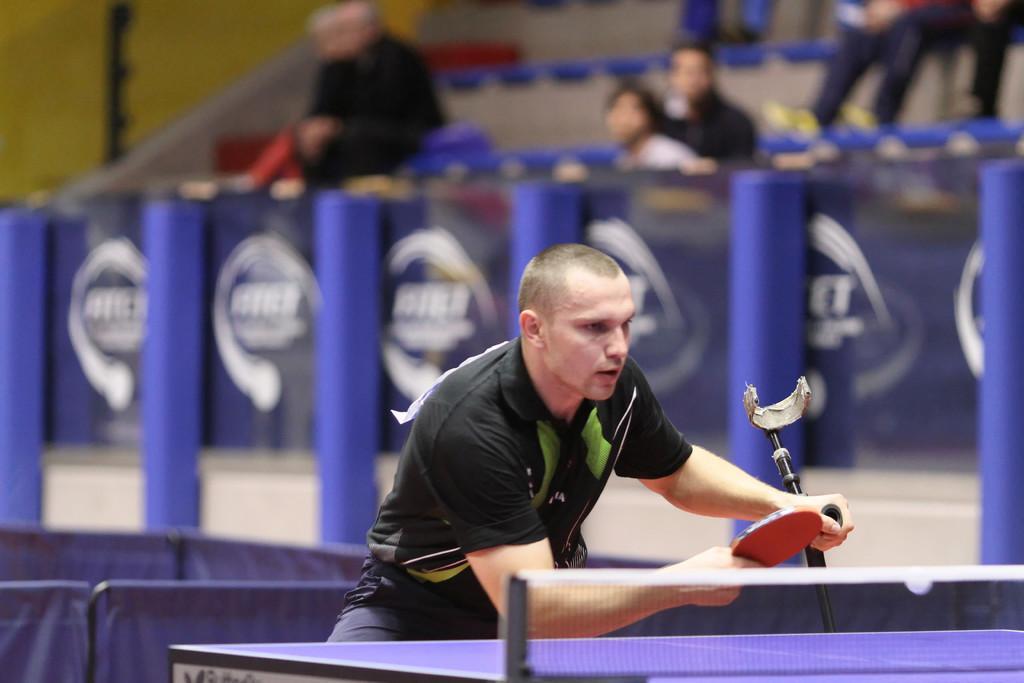How would you summarize this image in a sentence or two? a person is wearing a black t shirt and holding a table tennis bat in his hand. behind him there are few people watching him. 